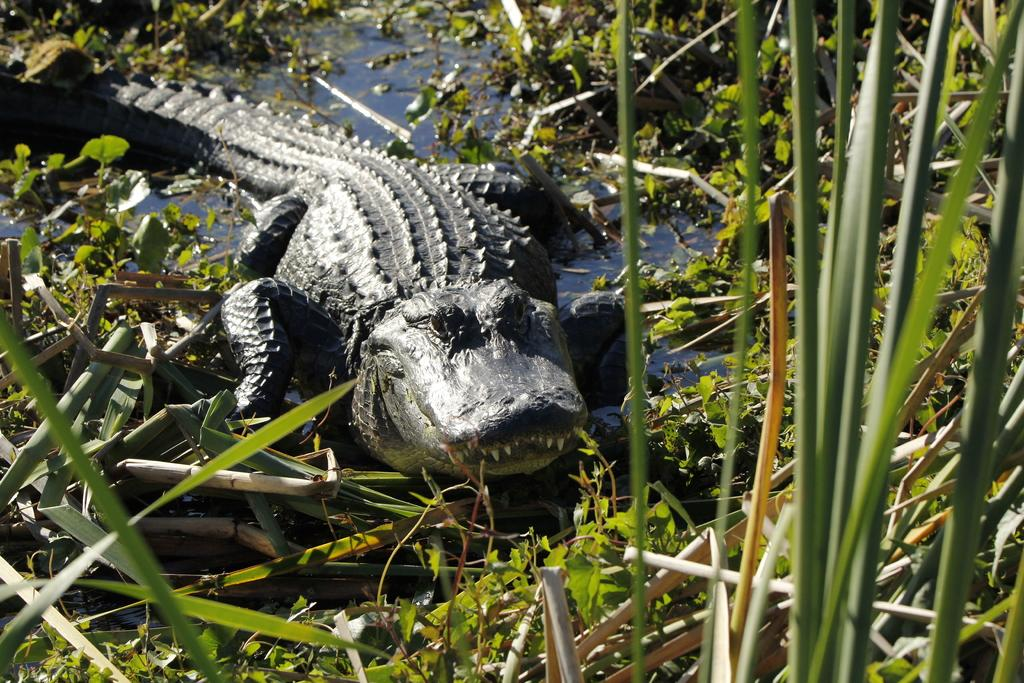What is the main subject in the center of the image? There is a crocodile in the water in the center of the image. What type of environment is depicted in the image? The image shows a watery environment with plants visible. Can you describe the water in the image? Yes, there is water visible in the image. What other objects can be seen in the image besides the crocodile and plants? There are a few other objects in the image. What time of day is it in the image, as indicated by the afternoon sun? There is no indication of the time of day in the image, and the presence or absence of an afternoon sun cannot be determined. 